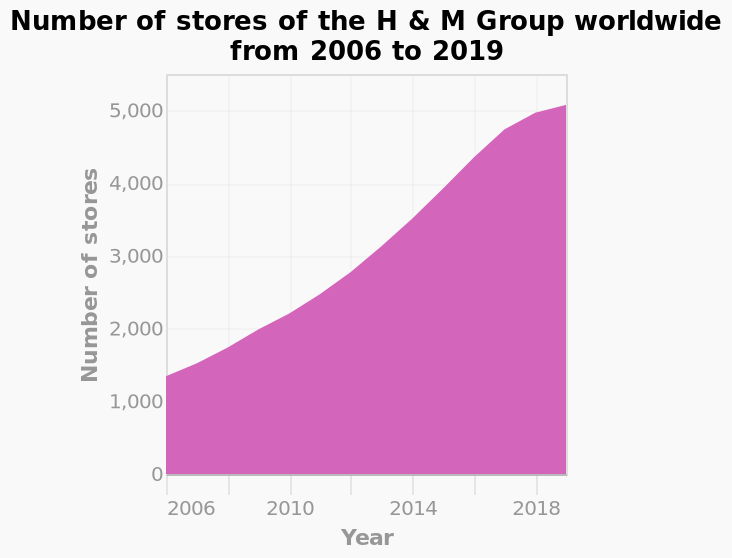<image>
What is the maximum value on the y-axis for the number of stores of the H & M Group worldwide?  The maximum value on the y-axis is 5,000. What can be concluded about the growth of H&M Group based on the area diagram? The area diagram clearly shows a significant increase in H&M Group stores over the years. please summary the statistics and relations of the chart Since 2016 the number of world wide h and m stores has steadily increased. In 2019 the number of stores has doubled since 2012, where there were around 2500 world wide stores. Offer a thorough analysis of the image. As time increases the number of stores increases regularly. How many H&M Group stores were added to the group every 4 years? Roughly 1,000 stores have been added to the H&M Group every 4 years. 